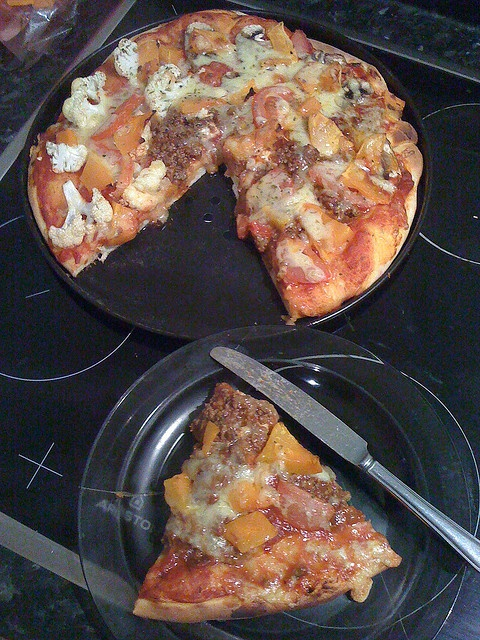Describe the objects in this image and their specific colors. I can see pizza in brown and tan tones and knife in brown, darkgray, and gray tones in this image. 